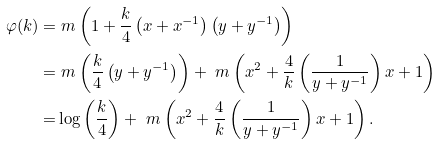<formula> <loc_0><loc_0><loc_500><loc_500>\varphi ( k ) = & \ m \left ( 1 + \frac { k } { 4 } \left ( x + x ^ { - 1 } \right ) \left ( y + y ^ { - 1 } \right ) \right ) \\ = & \ m \left ( \frac { k } { 4 } \left ( y + y ^ { - 1 } \right ) \right ) + \ m \left ( x ^ { 2 } + \frac { 4 } { k } \left ( \frac { 1 } { y + y ^ { - 1 } } \right ) x + 1 \right ) \\ = & \log \left ( \frac { k } { 4 } \right ) + \ m \left ( x ^ { 2 } + \frac { 4 } { k } \left ( \frac { 1 } { y + y ^ { - 1 } } \right ) x + 1 \right ) .</formula> 